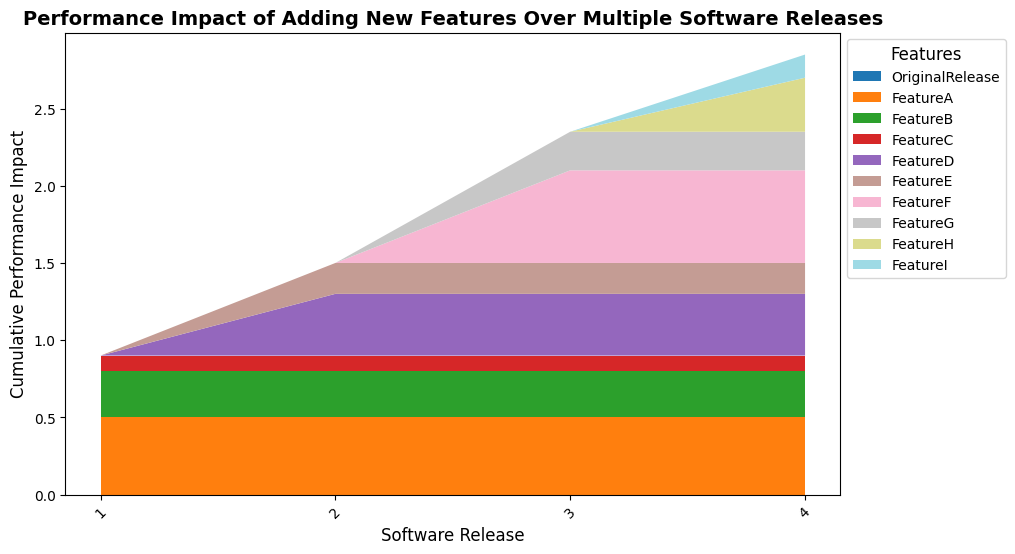Which software release has the highest cumulative performance impact overall? You can see from the height of the stack plot that Software Release 4 has the greatest cumulative performance impact as it reaches the highest point on the y-axis.
Answer: Software Release 4 What is the performance impact attributable to Feature F in Software Release 3? Locate the segment in the stack plot corresponding to Feature F at Software Release 3. The segment appears to be around 0.6 units in height.
Answer: 0.6 Comparing Feature A in all software releases, in which release does Feature A have a consistently similar impact? Feature A's segments in the stack plot across all software releases are at the same height of 0.5 units. Therefore, Feature A has a consistently similar impact in all releases.
Answer: All releases Which feature was added in Software Release 2 and what is its performance impact? By comparing the segments from Software Release 1 to Software Release 2, Feature D is new in Release 2. Its impact is observed in the stack plot segment that starts appearing from Release 2. Feature D has a performance impact of 0.4 units.
Answer: Feature D, 0.4 By how much did the performance impact of Feature E change from Software Release 2 to Software Release 4? Observe the height of the segment corresponding to Feature E in Software Release 2 and Software Release 4. In both releases, the height of the segment for Feature E is 0.2 units. Hence, the performance impact did not change.
Answer: 0.0 What is the cumulative performance impact of Feature A + Feature B in Software Release 1? In Software Release 1, add the segments corresponding to Feature A (0.5) and Feature B (0.3). The cumulative impact is 0.5 + 0.3 = 0.8 units.
Answer: 0.8 Which feature shows the highest performance impact in Software Release 4? In Software Release 4, look at the individual segments of the stack plot. Feature F has the highest segment at 0.6 units.
Answer: Feature F Which software release has the smallest cumulative performance impact and what is the value? Looking at the height of the stack plot, Software Release 1 has the smallest cumulative performance impact. The height reaches 0.9 units.
Answer: Software Release 1, 0.9 How did the cumulative impact of new features change from Software Release 3 to Software Release 4? Compare the heights of the stack plot at Software Release 3 and Software Release 4. The increase in height represents the cumulative impact of new features added between these releases. The height increase is observed from 0.65 (total height in Release 3) to 1.35 (total height in Release 4), a difference of 0.7 units.
Answer: Increased by 0.7 units In Software Release 2, by how much does the performance impact of Feature D exceed that of Feature C? The performance impact of Feature D in Software Release 2 is 0.4 units, and that of Feature C is 0.1 units. The difference is 0.4 - 0.1 = 0.3 units.
Answer: 0.3 